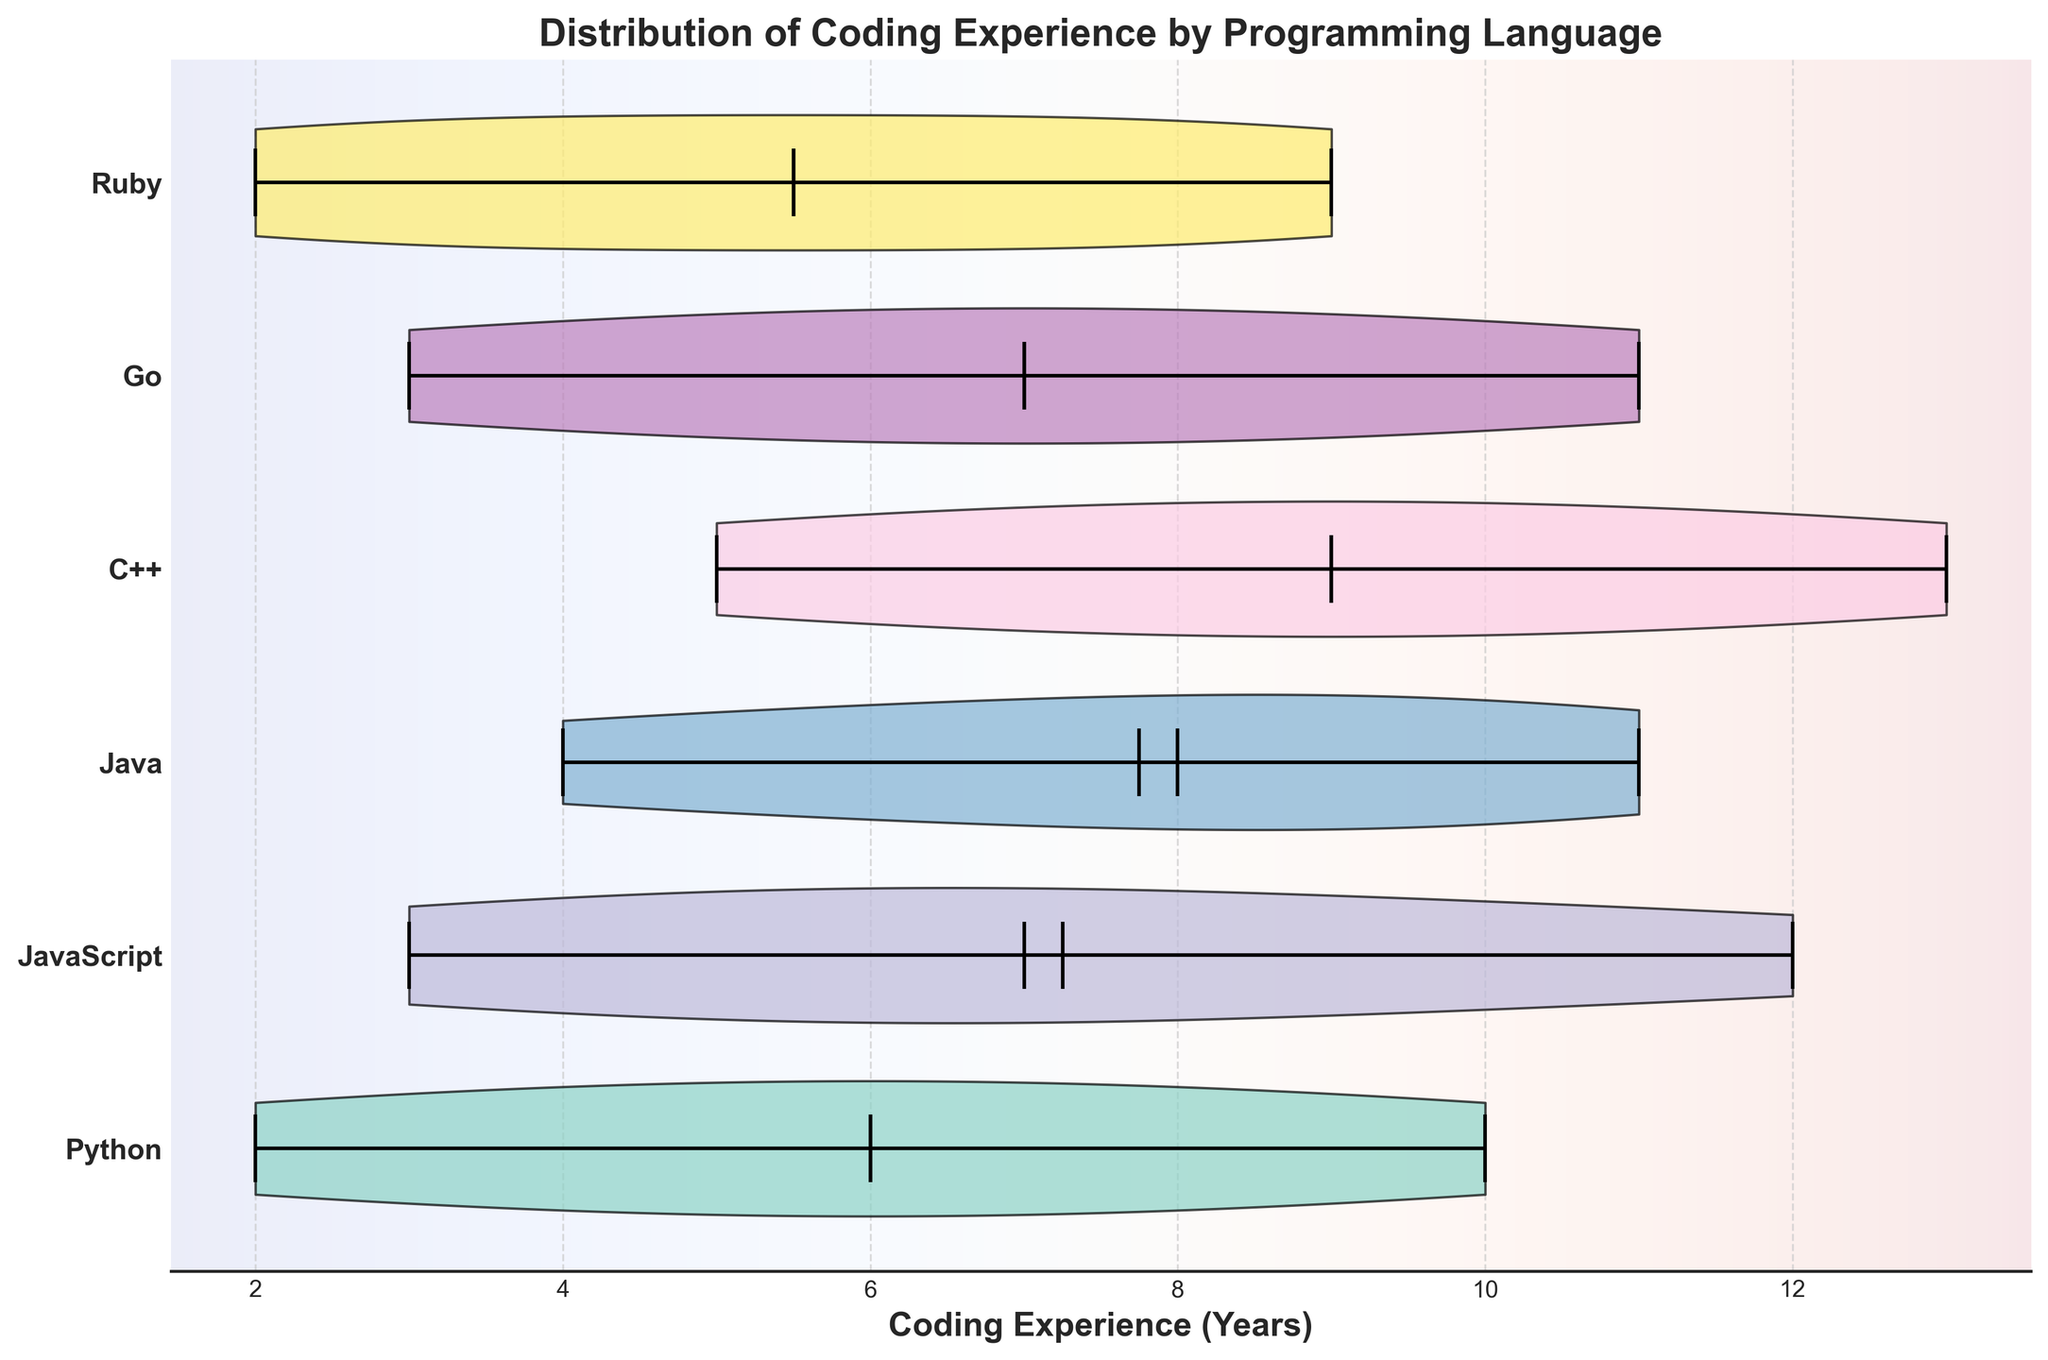What is the title of the figure? The title of the figure is usually located at the top of the plot and represents the main subject of the visualization. In this case, the title is "Distribution of Coding Experience by Programming Language".
Answer: Distribution of Coding Experience by Programming Language Which language has the highest median coding experience? To find the median coding experience for each language, we look at the horizontal line indicating the median within each violin plot. The language with the highest median line will be the answer.
Answer: C++ What are the y-axis labels representing? The y-axis labels in the horizontal violin chart represent the different programming languages for which the coding experience distribution is being displayed. Each tick on the y-axis corresponds to a different programming language.
Answer: Programming languages How do the median values of JavaScript and Ruby compare? To compare the median values, locate the horizontal lines within the JavaScript and Ruby violin plots. Compare their positions on the coding experience scale.
Answer: Ruby has a slightly higher median than JavaScript Which language has the widest spread of coding experience? The width of the spread in each violin plot indicates the variability in coding experience. Identify the language with the broadest horizontal spread within its violin plot.
Answer: C++ Are there any programming languages with the same median coding experience? To determine if any languages have the same median coding experience, compare the positions of the median lines in each violin plot. Check if any medians align horizontally.
Answer: No Which programming language has the lowest mean coding experience? Look for the bullet mark or horizontal line that represents the mean value for each language. Identify the language with the mean closest to the lower end of the x-axis.
Answer: Python For contributors with the maximum coding experience, which language do they predominantly use? Identify the language with the maximum coding experience by locating the furthest right point on the x-axis across all violin plots.
Answer: JavaScript If you were to pick a language where most contributors have around 7 years of experience, which one would it be? Look for the languages whose violin plots are densest around the 7-year mark on the x-axis. This indicates that a higher concentration of contributors has around 7 years of experience.
Answer: Python Would you say most contributors using Ruby have more or less experience compared to those using Java? Compare the density of the violin plots for Ruby and Java around higher values on the x-axis. More density indicates more contributors with greater experience.
Answer: Less experience 